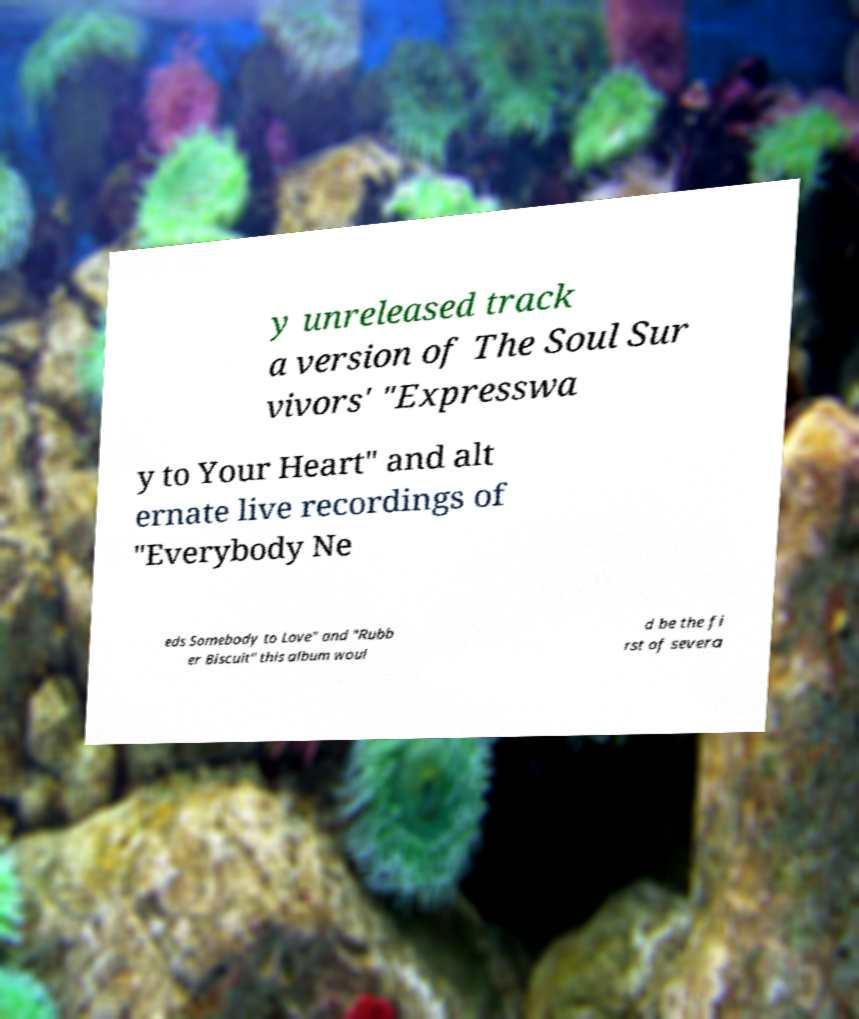What messages or text are displayed in this image? I need them in a readable, typed format. y unreleased track a version of The Soul Sur vivors' "Expresswa y to Your Heart" and alt ernate live recordings of "Everybody Ne eds Somebody to Love" and "Rubb er Biscuit" this album woul d be the fi rst of severa 